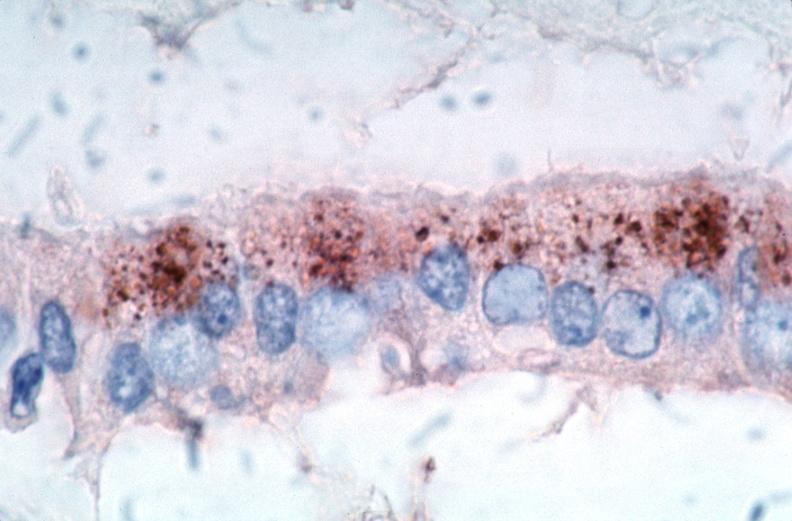what is vasculitis , rocky mountain spotted?
Answer the question using a single word or phrase. Fever immunoperoxidase staining vessels for rickettsia rickettsii 